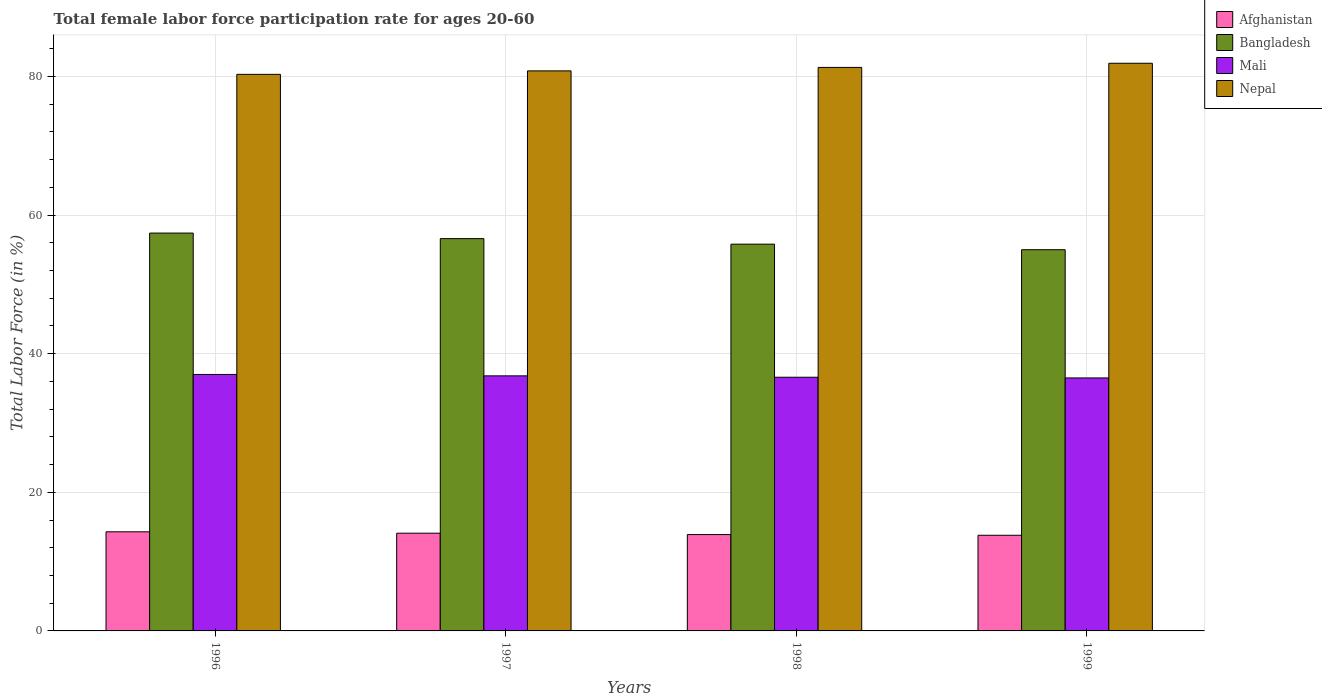How many different coloured bars are there?
Your response must be concise. 4. How many groups of bars are there?
Provide a short and direct response. 4. Are the number of bars per tick equal to the number of legend labels?
Make the answer very short. Yes. Are the number of bars on each tick of the X-axis equal?
Keep it short and to the point. Yes. What is the label of the 3rd group of bars from the left?
Give a very brief answer. 1998. In how many cases, is the number of bars for a given year not equal to the number of legend labels?
Make the answer very short. 0. What is the female labor force participation rate in Nepal in 1998?
Offer a very short reply. 81.3. Across all years, what is the maximum female labor force participation rate in Nepal?
Your answer should be compact. 81.9. Across all years, what is the minimum female labor force participation rate in Mali?
Provide a short and direct response. 36.5. In which year was the female labor force participation rate in Bangladesh maximum?
Keep it short and to the point. 1996. What is the total female labor force participation rate in Bangladesh in the graph?
Provide a short and direct response. 224.8. What is the difference between the female labor force participation rate in Nepal in 1997 and that in 1999?
Your response must be concise. -1.1. What is the difference between the female labor force participation rate in Afghanistan in 1997 and the female labor force participation rate in Nepal in 1996?
Give a very brief answer. -66.2. What is the average female labor force participation rate in Afghanistan per year?
Ensure brevity in your answer.  14.03. In the year 1998, what is the difference between the female labor force participation rate in Afghanistan and female labor force participation rate in Mali?
Your response must be concise. -22.7. What is the ratio of the female labor force participation rate in Afghanistan in 1997 to that in 1998?
Your response must be concise. 1.01. Is the female labor force participation rate in Afghanistan in 1998 less than that in 1999?
Offer a very short reply. No. Is the difference between the female labor force participation rate in Afghanistan in 1997 and 1999 greater than the difference between the female labor force participation rate in Mali in 1997 and 1999?
Give a very brief answer. Yes. What is the difference between the highest and the second highest female labor force participation rate in Mali?
Your answer should be compact. 0.2. In how many years, is the female labor force participation rate in Mali greater than the average female labor force participation rate in Mali taken over all years?
Make the answer very short. 2. Is the sum of the female labor force participation rate in Nepal in 1996 and 1999 greater than the maximum female labor force participation rate in Mali across all years?
Give a very brief answer. Yes. What does the 4th bar from the left in 1999 represents?
Offer a terse response. Nepal. What does the 1st bar from the right in 1998 represents?
Provide a succinct answer. Nepal. How many bars are there?
Provide a succinct answer. 16. Are all the bars in the graph horizontal?
Offer a terse response. No. How many years are there in the graph?
Make the answer very short. 4. Are the values on the major ticks of Y-axis written in scientific E-notation?
Offer a terse response. No. Where does the legend appear in the graph?
Offer a terse response. Top right. How are the legend labels stacked?
Your answer should be compact. Vertical. What is the title of the graph?
Keep it short and to the point. Total female labor force participation rate for ages 20-60. What is the label or title of the X-axis?
Your response must be concise. Years. What is the label or title of the Y-axis?
Keep it short and to the point. Total Labor Force (in %). What is the Total Labor Force (in %) in Afghanistan in 1996?
Your answer should be compact. 14.3. What is the Total Labor Force (in %) of Bangladesh in 1996?
Keep it short and to the point. 57.4. What is the Total Labor Force (in %) of Mali in 1996?
Your response must be concise. 37. What is the Total Labor Force (in %) of Nepal in 1996?
Ensure brevity in your answer.  80.3. What is the Total Labor Force (in %) in Afghanistan in 1997?
Your answer should be compact. 14.1. What is the Total Labor Force (in %) of Bangladesh in 1997?
Your answer should be compact. 56.6. What is the Total Labor Force (in %) of Mali in 1997?
Provide a short and direct response. 36.8. What is the Total Labor Force (in %) in Nepal in 1997?
Ensure brevity in your answer.  80.8. What is the Total Labor Force (in %) of Afghanistan in 1998?
Ensure brevity in your answer.  13.9. What is the Total Labor Force (in %) of Bangladesh in 1998?
Provide a succinct answer. 55.8. What is the Total Labor Force (in %) of Mali in 1998?
Your answer should be very brief. 36.6. What is the Total Labor Force (in %) of Nepal in 1998?
Ensure brevity in your answer.  81.3. What is the Total Labor Force (in %) in Afghanistan in 1999?
Keep it short and to the point. 13.8. What is the Total Labor Force (in %) in Mali in 1999?
Your answer should be compact. 36.5. What is the Total Labor Force (in %) in Nepal in 1999?
Offer a very short reply. 81.9. Across all years, what is the maximum Total Labor Force (in %) in Afghanistan?
Provide a succinct answer. 14.3. Across all years, what is the maximum Total Labor Force (in %) of Bangladesh?
Your answer should be very brief. 57.4. Across all years, what is the maximum Total Labor Force (in %) of Nepal?
Offer a very short reply. 81.9. Across all years, what is the minimum Total Labor Force (in %) of Afghanistan?
Your response must be concise. 13.8. Across all years, what is the minimum Total Labor Force (in %) in Mali?
Offer a very short reply. 36.5. Across all years, what is the minimum Total Labor Force (in %) in Nepal?
Keep it short and to the point. 80.3. What is the total Total Labor Force (in %) in Afghanistan in the graph?
Give a very brief answer. 56.1. What is the total Total Labor Force (in %) in Bangladesh in the graph?
Make the answer very short. 224.8. What is the total Total Labor Force (in %) in Mali in the graph?
Give a very brief answer. 146.9. What is the total Total Labor Force (in %) in Nepal in the graph?
Provide a short and direct response. 324.3. What is the difference between the Total Labor Force (in %) of Afghanistan in 1996 and that in 1997?
Make the answer very short. 0.2. What is the difference between the Total Labor Force (in %) in Bangladesh in 1996 and that in 1997?
Offer a very short reply. 0.8. What is the difference between the Total Labor Force (in %) of Mali in 1996 and that in 1997?
Offer a terse response. 0.2. What is the difference between the Total Labor Force (in %) of Nepal in 1996 and that in 1997?
Give a very brief answer. -0.5. What is the difference between the Total Labor Force (in %) of Afghanistan in 1996 and that in 1998?
Your answer should be very brief. 0.4. What is the difference between the Total Labor Force (in %) of Bangladesh in 1996 and that in 1998?
Ensure brevity in your answer.  1.6. What is the difference between the Total Labor Force (in %) of Mali in 1996 and that in 1998?
Offer a very short reply. 0.4. What is the difference between the Total Labor Force (in %) in Nepal in 1996 and that in 1998?
Give a very brief answer. -1. What is the difference between the Total Labor Force (in %) of Afghanistan in 1996 and that in 1999?
Offer a very short reply. 0.5. What is the difference between the Total Labor Force (in %) in Bangladesh in 1996 and that in 1999?
Make the answer very short. 2.4. What is the difference between the Total Labor Force (in %) in Afghanistan in 1997 and that in 1998?
Make the answer very short. 0.2. What is the difference between the Total Labor Force (in %) in Bangladesh in 1997 and that in 1998?
Provide a succinct answer. 0.8. What is the difference between the Total Labor Force (in %) in Afghanistan in 1997 and that in 1999?
Your answer should be very brief. 0.3. What is the difference between the Total Labor Force (in %) in Bangladesh in 1997 and that in 1999?
Your response must be concise. 1.6. What is the difference between the Total Labor Force (in %) of Nepal in 1997 and that in 1999?
Give a very brief answer. -1.1. What is the difference between the Total Labor Force (in %) in Afghanistan in 1998 and that in 1999?
Keep it short and to the point. 0.1. What is the difference between the Total Labor Force (in %) in Bangladesh in 1998 and that in 1999?
Give a very brief answer. 0.8. What is the difference between the Total Labor Force (in %) of Mali in 1998 and that in 1999?
Offer a terse response. 0.1. What is the difference between the Total Labor Force (in %) of Afghanistan in 1996 and the Total Labor Force (in %) of Bangladesh in 1997?
Provide a succinct answer. -42.3. What is the difference between the Total Labor Force (in %) of Afghanistan in 1996 and the Total Labor Force (in %) of Mali in 1997?
Offer a very short reply. -22.5. What is the difference between the Total Labor Force (in %) of Afghanistan in 1996 and the Total Labor Force (in %) of Nepal in 1997?
Offer a very short reply. -66.5. What is the difference between the Total Labor Force (in %) of Bangladesh in 1996 and the Total Labor Force (in %) of Mali in 1997?
Give a very brief answer. 20.6. What is the difference between the Total Labor Force (in %) in Bangladesh in 1996 and the Total Labor Force (in %) in Nepal in 1997?
Your answer should be very brief. -23.4. What is the difference between the Total Labor Force (in %) of Mali in 1996 and the Total Labor Force (in %) of Nepal in 1997?
Ensure brevity in your answer.  -43.8. What is the difference between the Total Labor Force (in %) in Afghanistan in 1996 and the Total Labor Force (in %) in Bangladesh in 1998?
Keep it short and to the point. -41.5. What is the difference between the Total Labor Force (in %) in Afghanistan in 1996 and the Total Labor Force (in %) in Mali in 1998?
Keep it short and to the point. -22.3. What is the difference between the Total Labor Force (in %) of Afghanistan in 1996 and the Total Labor Force (in %) of Nepal in 1998?
Offer a terse response. -67. What is the difference between the Total Labor Force (in %) of Bangladesh in 1996 and the Total Labor Force (in %) of Mali in 1998?
Your response must be concise. 20.8. What is the difference between the Total Labor Force (in %) of Bangladesh in 1996 and the Total Labor Force (in %) of Nepal in 1998?
Provide a succinct answer. -23.9. What is the difference between the Total Labor Force (in %) of Mali in 1996 and the Total Labor Force (in %) of Nepal in 1998?
Ensure brevity in your answer.  -44.3. What is the difference between the Total Labor Force (in %) of Afghanistan in 1996 and the Total Labor Force (in %) of Bangladesh in 1999?
Make the answer very short. -40.7. What is the difference between the Total Labor Force (in %) of Afghanistan in 1996 and the Total Labor Force (in %) of Mali in 1999?
Provide a succinct answer. -22.2. What is the difference between the Total Labor Force (in %) in Afghanistan in 1996 and the Total Labor Force (in %) in Nepal in 1999?
Offer a terse response. -67.6. What is the difference between the Total Labor Force (in %) of Bangladesh in 1996 and the Total Labor Force (in %) of Mali in 1999?
Your response must be concise. 20.9. What is the difference between the Total Labor Force (in %) of Bangladesh in 1996 and the Total Labor Force (in %) of Nepal in 1999?
Offer a very short reply. -24.5. What is the difference between the Total Labor Force (in %) in Mali in 1996 and the Total Labor Force (in %) in Nepal in 1999?
Offer a terse response. -44.9. What is the difference between the Total Labor Force (in %) in Afghanistan in 1997 and the Total Labor Force (in %) in Bangladesh in 1998?
Make the answer very short. -41.7. What is the difference between the Total Labor Force (in %) of Afghanistan in 1997 and the Total Labor Force (in %) of Mali in 1998?
Ensure brevity in your answer.  -22.5. What is the difference between the Total Labor Force (in %) in Afghanistan in 1997 and the Total Labor Force (in %) in Nepal in 1998?
Give a very brief answer. -67.2. What is the difference between the Total Labor Force (in %) in Bangladesh in 1997 and the Total Labor Force (in %) in Mali in 1998?
Give a very brief answer. 20. What is the difference between the Total Labor Force (in %) in Bangladesh in 1997 and the Total Labor Force (in %) in Nepal in 1998?
Keep it short and to the point. -24.7. What is the difference between the Total Labor Force (in %) in Mali in 1997 and the Total Labor Force (in %) in Nepal in 1998?
Your answer should be compact. -44.5. What is the difference between the Total Labor Force (in %) in Afghanistan in 1997 and the Total Labor Force (in %) in Bangladesh in 1999?
Your answer should be very brief. -40.9. What is the difference between the Total Labor Force (in %) of Afghanistan in 1997 and the Total Labor Force (in %) of Mali in 1999?
Your answer should be very brief. -22.4. What is the difference between the Total Labor Force (in %) in Afghanistan in 1997 and the Total Labor Force (in %) in Nepal in 1999?
Provide a short and direct response. -67.8. What is the difference between the Total Labor Force (in %) in Bangladesh in 1997 and the Total Labor Force (in %) in Mali in 1999?
Keep it short and to the point. 20.1. What is the difference between the Total Labor Force (in %) in Bangladesh in 1997 and the Total Labor Force (in %) in Nepal in 1999?
Offer a terse response. -25.3. What is the difference between the Total Labor Force (in %) in Mali in 1997 and the Total Labor Force (in %) in Nepal in 1999?
Provide a short and direct response. -45.1. What is the difference between the Total Labor Force (in %) in Afghanistan in 1998 and the Total Labor Force (in %) in Bangladesh in 1999?
Offer a terse response. -41.1. What is the difference between the Total Labor Force (in %) in Afghanistan in 1998 and the Total Labor Force (in %) in Mali in 1999?
Offer a terse response. -22.6. What is the difference between the Total Labor Force (in %) in Afghanistan in 1998 and the Total Labor Force (in %) in Nepal in 1999?
Ensure brevity in your answer.  -68. What is the difference between the Total Labor Force (in %) of Bangladesh in 1998 and the Total Labor Force (in %) of Mali in 1999?
Offer a terse response. 19.3. What is the difference between the Total Labor Force (in %) of Bangladesh in 1998 and the Total Labor Force (in %) of Nepal in 1999?
Your answer should be compact. -26.1. What is the difference between the Total Labor Force (in %) in Mali in 1998 and the Total Labor Force (in %) in Nepal in 1999?
Keep it short and to the point. -45.3. What is the average Total Labor Force (in %) of Afghanistan per year?
Offer a very short reply. 14.03. What is the average Total Labor Force (in %) in Bangladesh per year?
Your answer should be compact. 56.2. What is the average Total Labor Force (in %) in Mali per year?
Give a very brief answer. 36.73. What is the average Total Labor Force (in %) of Nepal per year?
Provide a succinct answer. 81.08. In the year 1996, what is the difference between the Total Labor Force (in %) in Afghanistan and Total Labor Force (in %) in Bangladesh?
Give a very brief answer. -43.1. In the year 1996, what is the difference between the Total Labor Force (in %) of Afghanistan and Total Labor Force (in %) of Mali?
Offer a very short reply. -22.7. In the year 1996, what is the difference between the Total Labor Force (in %) of Afghanistan and Total Labor Force (in %) of Nepal?
Provide a succinct answer. -66. In the year 1996, what is the difference between the Total Labor Force (in %) of Bangladesh and Total Labor Force (in %) of Mali?
Provide a short and direct response. 20.4. In the year 1996, what is the difference between the Total Labor Force (in %) in Bangladesh and Total Labor Force (in %) in Nepal?
Your response must be concise. -22.9. In the year 1996, what is the difference between the Total Labor Force (in %) in Mali and Total Labor Force (in %) in Nepal?
Offer a very short reply. -43.3. In the year 1997, what is the difference between the Total Labor Force (in %) of Afghanistan and Total Labor Force (in %) of Bangladesh?
Provide a succinct answer. -42.5. In the year 1997, what is the difference between the Total Labor Force (in %) in Afghanistan and Total Labor Force (in %) in Mali?
Your response must be concise. -22.7. In the year 1997, what is the difference between the Total Labor Force (in %) of Afghanistan and Total Labor Force (in %) of Nepal?
Your answer should be very brief. -66.7. In the year 1997, what is the difference between the Total Labor Force (in %) in Bangladesh and Total Labor Force (in %) in Mali?
Keep it short and to the point. 19.8. In the year 1997, what is the difference between the Total Labor Force (in %) in Bangladesh and Total Labor Force (in %) in Nepal?
Offer a terse response. -24.2. In the year 1997, what is the difference between the Total Labor Force (in %) in Mali and Total Labor Force (in %) in Nepal?
Your answer should be very brief. -44. In the year 1998, what is the difference between the Total Labor Force (in %) in Afghanistan and Total Labor Force (in %) in Bangladesh?
Offer a very short reply. -41.9. In the year 1998, what is the difference between the Total Labor Force (in %) of Afghanistan and Total Labor Force (in %) of Mali?
Make the answer very short. -22.7. In the year 1998, what is the difference between the Total Labor Force (in %) in Afghanistan and Total Labor Force (in %) in Nepal?
Your answer should be very brief. -67.4. In the year 1998, what is the difference between the Total Labor Force (in %) of Bangladesh and Total Labor Force (in %) of Mali?
Give a very brief answer. 19.2. In the year 1998, what is the difference between the Total Labor Force (in %) of Bangladesh and Total Labor Force (in %) of Nepal?
Ensure brevity in your answer.  -25.5. In the year 1998, what is the difference between the Total Labor Force (in %) in Mali and Total Labor Force (in %) in Nepal?
Offer a terse response. -44.7. In the year 1999, what is the difference between the Total Labor Force (in %) in Afghanistan and Total Labor Force (in %) in Bangladesh?
Make the answer very short. -41.2. In the year 1999, what is the difference between the Total Labor Force (in %) in Afghanistan and Total Labor Force (in %) in Mali?
Ensure brevity in your answer.  -22.7. In the year 1999, what is the difference between the Total Labor Force (in %) of Afghanistan and Total Labor Force (in %) of Nepal?
Provide a succinct answer. -68.1. In the year 1999, what is the difference between the Total Labor Force (in %) in Bangladesh and Total Labor Force (in %) in Nepal?
Ensure brevity in your answer.  -26.9. In the year 1999, what is the difference between the Total Labor Force (in %) of Mali and Total Labor Force (in %) of Nepal?
Your response must be concise. -45.4. What is the ratio of the Total Labor Force (in %) in Afghanistan in 1996 to that in 1997?
Provide a short and direct response. 1.01. What is the ratio of the Total Labor Force (in %) of Bangladesh in 1996 to that in 1997?
Offer a terse response. 1.01. What is the ratio of the Total Labor Force (in %) of Mali in 1996 to that in 1997?
Keep it short and to the point. 1.01. What is the ratio of the Total Labor Force (in %) of Nepal in 1996 to that in 1997?
Make the answer very short. 0.99. What is the ratio of the Total Labor Force (in %) in Afghanistan in 1996 to that in 1998?
Make the answer very short. 1.03. What is the ratio of the Total Labor Force (in %) in Bangladesh in 1996 to that in 1998?
Make the answer very short. 1.03. What is the ratio of the Total Labor Force (in %) in Mali in 1996 to that in 1998?
Keep it short and to the point. 1.01. What is the ratio of the Total Labor Force (in %) in Nepal in 1996 to that in 1998?
Your answer should be compact. 0.99. What is the ratio of the Total Labor Force (in %) in Afghanistan in 1996 to that in 1999?
Make the answer very short. 1.04. What is the ratio of the Total Labor Force (in %) in Bangladesh in 1996 to that in 1999?
Your answer should be compact. 1.04. What is the ratio of the Total Labor Force (in %) of Mali in 1996 to that in 1999?
Offer a terse response. 1.01. What is the ratio of the Total Labor Force (in %) in Nepal in 1996 to that in 1999?
Keep it short and to the point. 0.98. What is the ratio of the Total Labor Force (in %) of Afghanistan in 1997 to that in 1998?
Offer a terse response. 1.01. What is the ratio of the Total Labor Force (in %) of Bangladesh in 1997 to that in 1998?
Keep it short and to the point. 1.01. What is the ratio of the Total Labor Force (in %) in Mali in 1997 to that in 1998?
Your answer should be very brief. 1.01. What is the ratio of the Total Labor Force (in %) in Afghanistan in 1997 to that in 1999?
Make the answer very short. 1.02. What is the ratio of the Total Labor Force (in %) in Bangladesh in 1997 to that in 1999?
Your response must be concise. 1.03. What is the ratio of the Total Labor Force (in %) of Mali in 1997 to that in 1999?
Provide a short and direct response. 1.01. What is the ratio of the Total Labor Force (in %) in Nepal in 1997 to that in 1999?
Keep it short and to the point. 0.99. What is the ratio of the Total Labor Force (in %) of Afghanistan in 1998 to that in 1999?
Provide a succinct answer. 1.01. What is the ratio of the Total Labor Force (in %) of Bangladesh in 1998 to that in 1999?
Ensure brevity in your answer.  1.01. What is the difference between the highest and the second highest Total Labor Force (in %) of Afghanistan?
Make the answer very short. 0.2. What is the difference between the highest and the second highest Total Labor Force (in %) of Nepal?
Ensure brevity in your answer.  0.6. What is the difference between the highest and the lowest Total Labor Force (in %) of Afghanistan?
Give a very brief answer. 0.5. What is the difference between the highest and the lowest Total Labor Force (in %) in Bangladesh?
Offer a terse response. 2.4. What is the difference between the highest and the lowest Total Labor Force (in %) in Mali?
Your answer should be very brief. 0.5. What is the difference between the highest and the lowest Total Labor Force (in %) in Nepal?
Your answer should be very brief. 1.6. 